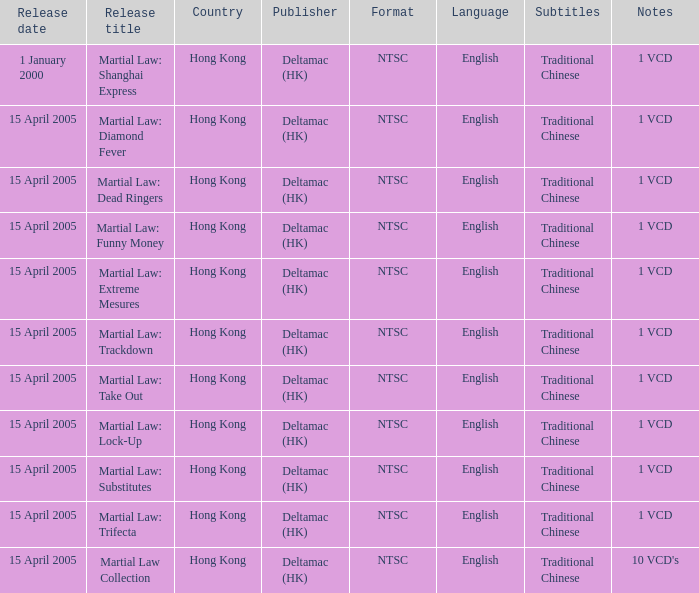In which country was 1 vcd titled martial law: substitutes released? Hong Kong. 